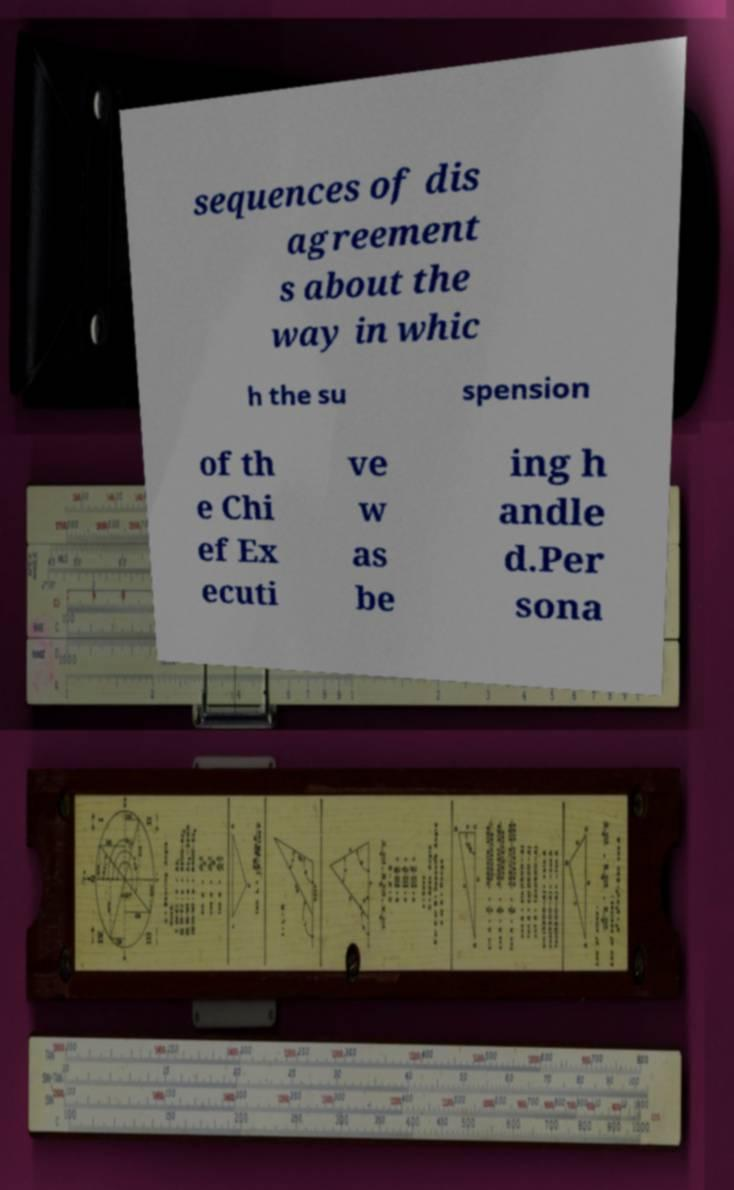Can you accurately transcribe the text from the provided image for me? sequences of dis agreement s about the way in whic h the su spension of th e Chi ef Ex ecuti ve w as be ing h andle d.Per sona 